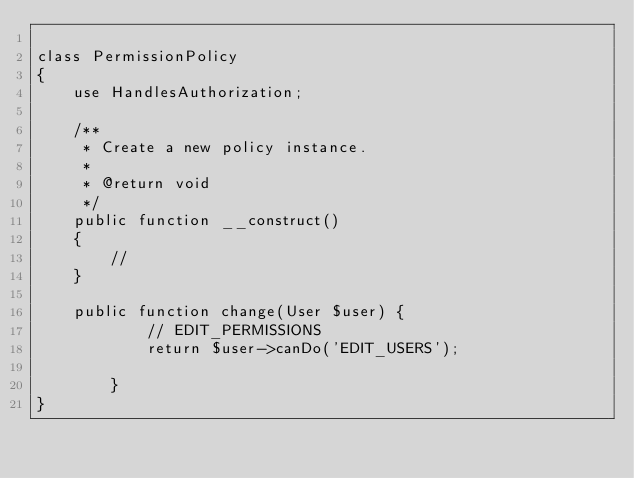<code> <loc_0><loc_0><loc_500><loc_500><_PHP_>
class PermissionPolicy
{
    use HandlesAuthorization;

    /**
     * Create a new policy instance.
     *
     * @return void
     */
    public function __construct()
    {
        //
    }

    public function change(User $user) {
            // EDIT_PERMISSIONS
            return $user->canDo('EDIT_USERS');

        }
}
</code> 